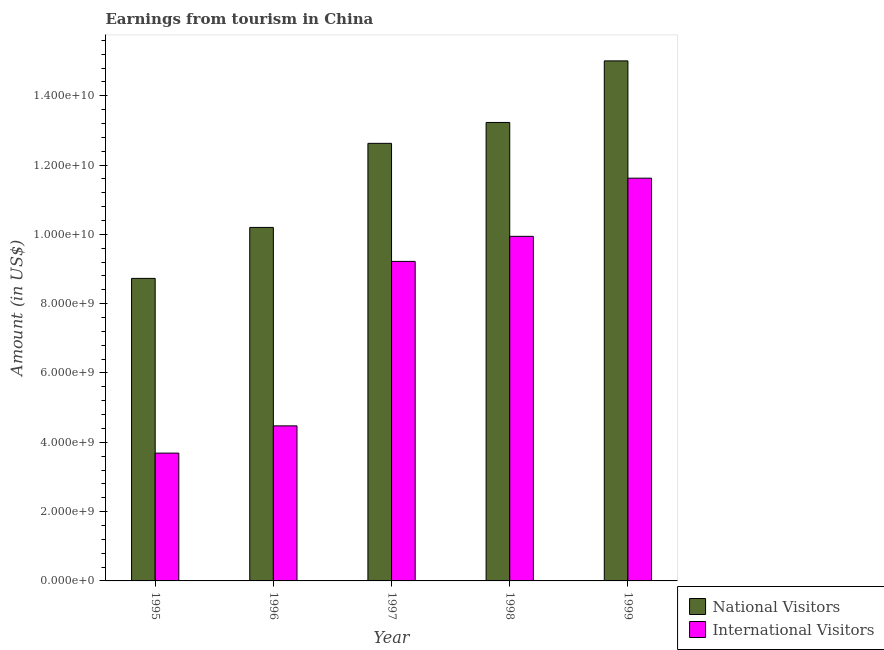How many groups of bars are there?
Provide a short and direct response. 5. Are the number of bars per tick equal to the number of legend labels?
Your answer should be very brief. Yes. Are the number of bars on each tick of the X-axis equal?
Your answer should be very brief. Yes. How many bars are there on the 5th tick from the right?
Your response must be concise. 2. In how many cases, is the number of bars for a given year not equal to the number of legend labels?
Offer a very short reply. 0. What is the amount earned from national visitors in 1995?
Provide a succinct answer. 8.73e+09. Across all years, what is the maximum amount earned from international visitors?
Ensure brevity in your answer.  1.16e+1. Across all years, what is the minimum amount earned from national visitors?
Provide a succinct answer. 8.73e+09. In which year was the amount earned from international visitors maximum?
Make the answer very short. 1999. In which year was the amount earned from national visitors minimum?
Make the answer very short. 1995. What is the total amount earned from international visitors in the graph?
Give a very brief answer. 3.89e+1. What is the difference between the amount earned from national visitors in 1995 and that in 1999?
Make the answer very short. -6.28e+09. What is the difference between the amount earned from international visitors in 1997 and the amount earned from national visitors in 1998?
Ensure brevity in your answer.  -7.23e+08. What is the average amount earned from national visitors per year?
Offer a very short reply. 1.20e+1. In how many years, is the amount earned from national visitors greater than 5600000000 US$?
Your answer should be compact. 5. What is the ratio of the amount earned from international visitors in 1997 to that in 1998?
Offer a terse response. 0.93. Is the amount earned from national visitors in 1995 less than that in 1997?
Your answer should be very brief. Yes. What is the difference between the highest and the second highest amount earned from national visitors?
Offer a terse response. 1.78e+09. What is the difference between the highest and the lowest amount earned from national visitors?
Keep it short and to the point. 6.28e+09. What does the 1st bar from the left in 1997 represents?
Ensure brevity in your answer.  National Visitors. What does the 1st bar from the right in 1999 represents?
Give a very brief answer. International Visitors. How many bars are there?
Your answer should be compact. 10. How many years are there in the graph?
Give a very brief answer. 5. What is the difference between two consecutive major ticks on the Y-axis?
Give a very brief answer. 2.00e+09. Does the graph contain grids?
Offer a terse response. No. Where does the legend appear in the graph?
Offer a terse response. Bottom right. How many legend labels are there?
Give a very brief answer. 2. How are the legend labels stacked?
Offer a very short reply. Vertical. What is the title of the graph?
Provide a short and direct response. Earnings from tourism in China. Does "State government" appear as one of the legend labels in the graph?
Your response must be concise. No. What is the label or title of the X-axis?
Provide a short and direct response. Year. What is the Amount (in US$) in National Visitors in 1995?
Provide a succinct answer. 8.73e+09. What is the Amount (in US$) of International Visitors in 1995?
Make the answer very short. 3.69e+09. What is the Amount (in US$) in National Visitors in 1996?
Give a very brief answer. 1.02e+1. What is the Amount (in US$) of International Visitors in 1996?
Ensure brevity in your answer.  4.47e+09. What is the Amount (in US$) of National Visitors in 1997?
Keep it short and to the point. 1.26e+1. What is the Amount (in US$) of International Visitors in 1997?
Your answer should be compact. 9.22e+09. What is the Amount (in US$) in National Visitors in 1998?
Provide a short and direct response. 1.32e+1. What is the Amount (in US$) of International Visitors in 1998?
Your answer should be very brief. 9.94e+09. What is the Amount (in US$) of National Visitors in 1999?
Your answer should be very brief. 1.50e+1. What is the Amount (in US$) in International Visitors in 1999?
Ensure brevity in your answer.  1.16e+1. Across all years, what is the maximum Amount (in US$) in National Visitors?
Keep it short and to the point. 1.50e+1. Across all years, what is the maximum Amount (in US$) of International Visitors?
Give a very brief answer. 1.16e+1. Across all years, what is the minimum Amount (in US$) of National Visitors?
Keep it short and to the point. 8.73e+09. Across all years, what is the minimum Amount (in US$) in International Visitors?
Keep it short and to the point. 3.69e+09. What is the total Amount (in US$) of National Visitors in the graph?
Your response must be concise. 5.98e+1. What is the total Amount (in US$) of International Visitors in the graph?
Provide a succinct answer. 3.89e+1. What is the difference between the Amount (in US$) of National Visitors in 1995 and that in 1996?
Your answer should be very brief. -1.47e+09. What is the difference between the Amount (in US$) of International Visitors in 1995 and that in 1996?
Provide a short and direct response. -7.86e+08. What is the difference between the Amount (in US$) in National Visitors in 1995 and that in 1997?
Provide a short and direct response. -3.90e+09. What is the difference between the Amount (in US$) in International Visitors in 1995 and that in 1997?
Give a very brief answer. -5.53e+09. What is the difference between the Amount (in US$) in National Visitors in 1995 and that in 1998?
Give a very brief answer. -4.50e+09. What is the difference between the Amount (in US$) of International Visitors in 1995 and that in 1998?
Provide a succinct answer. -6.26e+09. What is the difference between the Amount (in US$) of National Visitors in 1995 and that in 1999?
Make the answer very short. -6.28e+09. What is the difference between the Amount (in US$) in International Visitors in 1995 and that in 1999?
Your answer should be compact. -7.93e+09. What is the difference between the Amount (in US$) in National Visitors in 1996 and that in 1997?
Provide a short and direct response. -2.43e+09. What is the difference between the Amount (in US$) in International Visitors in 1996 and that in 1997?
Provide a short and direct response. -4.75e+09. What is the difference between the Amount (in US$) in National Visitors in 1996 and that in 1998?
Make the answer very short. -3.03e+09. What is the difference between the Amount (in US$) in International Visitors in 1996 and that in 1998?
Provide a short and direct response. -5.47e+09. What is the difference between the Amount (in US$) in National Visitors in 1996 and that in 1999?
Your answer should be very brief. -4.81e+09. What is the difference between the Amount (in US$) of International Visitors in 1996 and that in 1999?
Keep it short and to the point. -7.15e+09. What is the difference between the Amount (in US$) in National Visitors in 1997 and that in 1998?
Provide a succinct answer. -6.03e+08. What is the difference between the Amount (in US$) of International Visitors in 1997 and that in 1998?
Your answer should be compact. -7.23e+08. What is the difference between the Amount (in US$) in National Visitors in 1997 and that in 1999?
Your response must be concise. -2.38e+09. What is the difference between the Amount (in US$) in International Visitors in 1997 and that in 1999?
Provide a short and direct response. -2.40e+09. What is the difference between the Amount (in US$) in National Visitors in 1998 and that in 1999?
Give a very brief answer. -1.78e+09. What is the difference between the Amount (in US$) in International Visitors in 1998 and that in 1999?
Keep it short and to the point. -1.68e+09. What is the difference between the Amount (in US$) of National Visitors in 1995 and the Amount (in US$) of International Visitors in 1996?
Your answer should be compact. 4.26e+09. What is the difference between the Amount (in US$) of National Visitors in 1995 and the Amount (in US$) of International Visitors in 1997?
Provide a succinct answer. -4.90e+08. What is the difference between the Amount (in US$) in National Visitors in 1995 and the Amount (in US$) in International Visitors in 1998?
Ensure brevity in your answer.  -1.21e+09. What is the difference between the Amount (in US$) of National Visitors in 1995 and the Amount (in US$) of International Visitors in 1999?
Provide a short and direct response. -2.89e+09. What is the difference between the Amount (in US$) in National Visitors in 1996 and the Amount (in US$) in International Visitors in 1997?
Make the answer very short. 9.80e+08. What is the difference between the Amount (in US$) of National Visitors in 1996 and the Amount (in US$) of International Visitors in 1998?
Your response must be concise. 2.57e+08. What is the difference between the Amount (in US$) in National Visitors in 1996 and the Amount (in US$) in International Visitors in 1999?
Your answer should be very brief. -1.42e+09. What is the difference between the Amount (in US$) of National Visitors in 1997 and the Amount (in US$) of International Visitors in 1998?
Your response must be concise. 2.68e+09. What is the difference between the Amount (in US$) in National Visitors in 1997 and the Amount (in US$) in International Visitors in 1999?
Make the answer very short. 1.00e+09. What is the difference between the Amount (in US$) in National Visitors in 1998 and the Amount (in US$) in International Visitors in 1999?
Offer a very short reply. 1.61e+09. What is the average Amount (in US$) of National Visitors per year?
Offer a terse response. 1.20e+1. What is the average Amount (in US$) of International Visitors per year?
Keep it short and to the point. 7.79e+09. In the year 1995, what is the difference between the Amount (in US$) of National Visitors and Amount (in US$) of International Visitors?
Provide a succinct answer. 5.04e+09. In the year 1996, what is the difference between the Amount (in US$) of National Visitors and Amount (in US$) of International Visitors?
Offer a terse response. 5.73e+09. In the year 1997, what is the difference between the Amount (in US$) in National Visitors and Amount (in US$) in International Visitors?
Your answer should be compact. 3.41e+09. In the year 1998, what is the difference between the Amount (in US$) of National Visitors and Amount (in US$) of International Visitors?
Ensure brevity in your answer.  3.29e+09. In the year 1999, what is the difference between the Amount (in US$) in National Visitors and Amount (in US$) in International Visitors?
Give a very brief answer. 3.38e+09. What is the ratio of the Amount (in US$) in National Visitors in 1995 to that in 1996?
Offer a very short reply. 0.86. What is the ratio of the Amount (in US$) of International Visitors in 1995 to that in 1996?
Your response must be concise. 0.82. What is the ratio of the Amount (in US$) of National Visitors in 1995 to that in 1997?
Your answer should be compact. 0.69. What is the ratio of the Amount (in US$) in International Visitors in 1995 to that in 1997?
Offer a very short reply. 0.4. What is the ratio of the Amount (in US$) in National Visitors in 1995 to that in 1998?
Give a very brief answer. 0.66. What is the ratio of the Amount (in US$) of International Visitors in 1995 to that in 1998?
Provide a short and direct response. 0.37. What is the ratio of the Amount (in US$) in National Visitors in 1995 to that in 1999?
Make the answer very short. 0.58. What is the ratio of the Amount (in US$) in International Visitors in 1995 to that in 1999?
Make the answer very short. 0.32. What is the ratio of the Amount (in US$) in National Visitors in 1996 to that in 1997?
Offer a terse response. 0.81. What is the ratio of the Amount (in US$) of International Visitors in 1996 to that in 1997?
Give a very brief answer. 0.49. What is the ratio of the Amount (in US$) of National Visitors in 1996 to that in 1998?
Your answer should be very brief. 0.77. What is the ratio of the Amount (in US$) in International Visitors in 1996 to that in 1998?
Keep it short and to the point. 0.45. What is the ratio of the Amount (in US$) of National Visitors in 1996 to that in 1999?
Provide a succinct answer. 0.68. What is the ratio of the Amount (in US$) of International Visitors in 1996 to that in 1999?
Ensure brevity in your answer.  0.39. What is the ratio of the Amount (in US$) in National Visitors in 1997 to that in 1998?
Offer a terse response. 0.95. What is the ratio of the Amount (in US$) in International Visitors in 1997 to that in 1998?
Provide a succinct answer. 0.93. What is the ratio of the Amount (in US$) of National Visitors in 1997 to that in 1999?
Make the answer very short. 0.84. What is the ratio of the Amount (in US$) in International Visitors in 1997 to that in 1999?
Your answer should be very brief. 0.79. What is the ratio of the Amount (in US$) of National Visitors in 1998 to that in 1999?
Provide a succinct answer. 0.88. What is the ratio of the Amount (in US$) in International Visitors in 1998 to that in 1999?
Offer a terse response. 0.86. What is the difference between the highest and the second highest Amount (in US$) of National Visitors?
Give a very brief answer. 1.78e+09. What is the difference between the highest and the second highest Amount (in US$) in International Visitors?
Keep it short and to the point. 1.68e+09. What is the difference between the highest and the lowest Amount (in US$) in National Visitors?
Offer a terse response. 6.28e+09. What is the difference between the highest and the lowest Amount (in US$) of International Visitors?
Keep it short and to the point. 7.93e+09. 